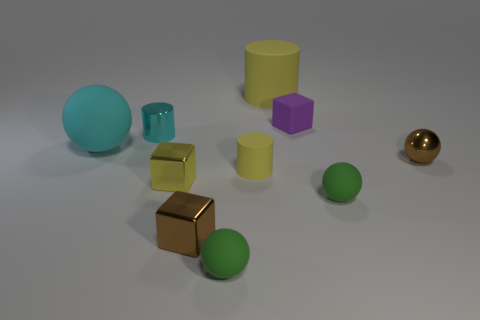Subtract 1 spheres. How many spheres are left? 3 Subtract all blocks. How many objects are left? 7 Add 3 big red matte balls. How many big red matte balls exist? 3 Subtract 0 purple balls. How many objects are left? 10 Subtract all gray blocks. Subtract all tiny cyan metallic cylinders. How many objects are left? 9 Add 6 cyan shiny objects. How many cyan shiny objects are left? 7 